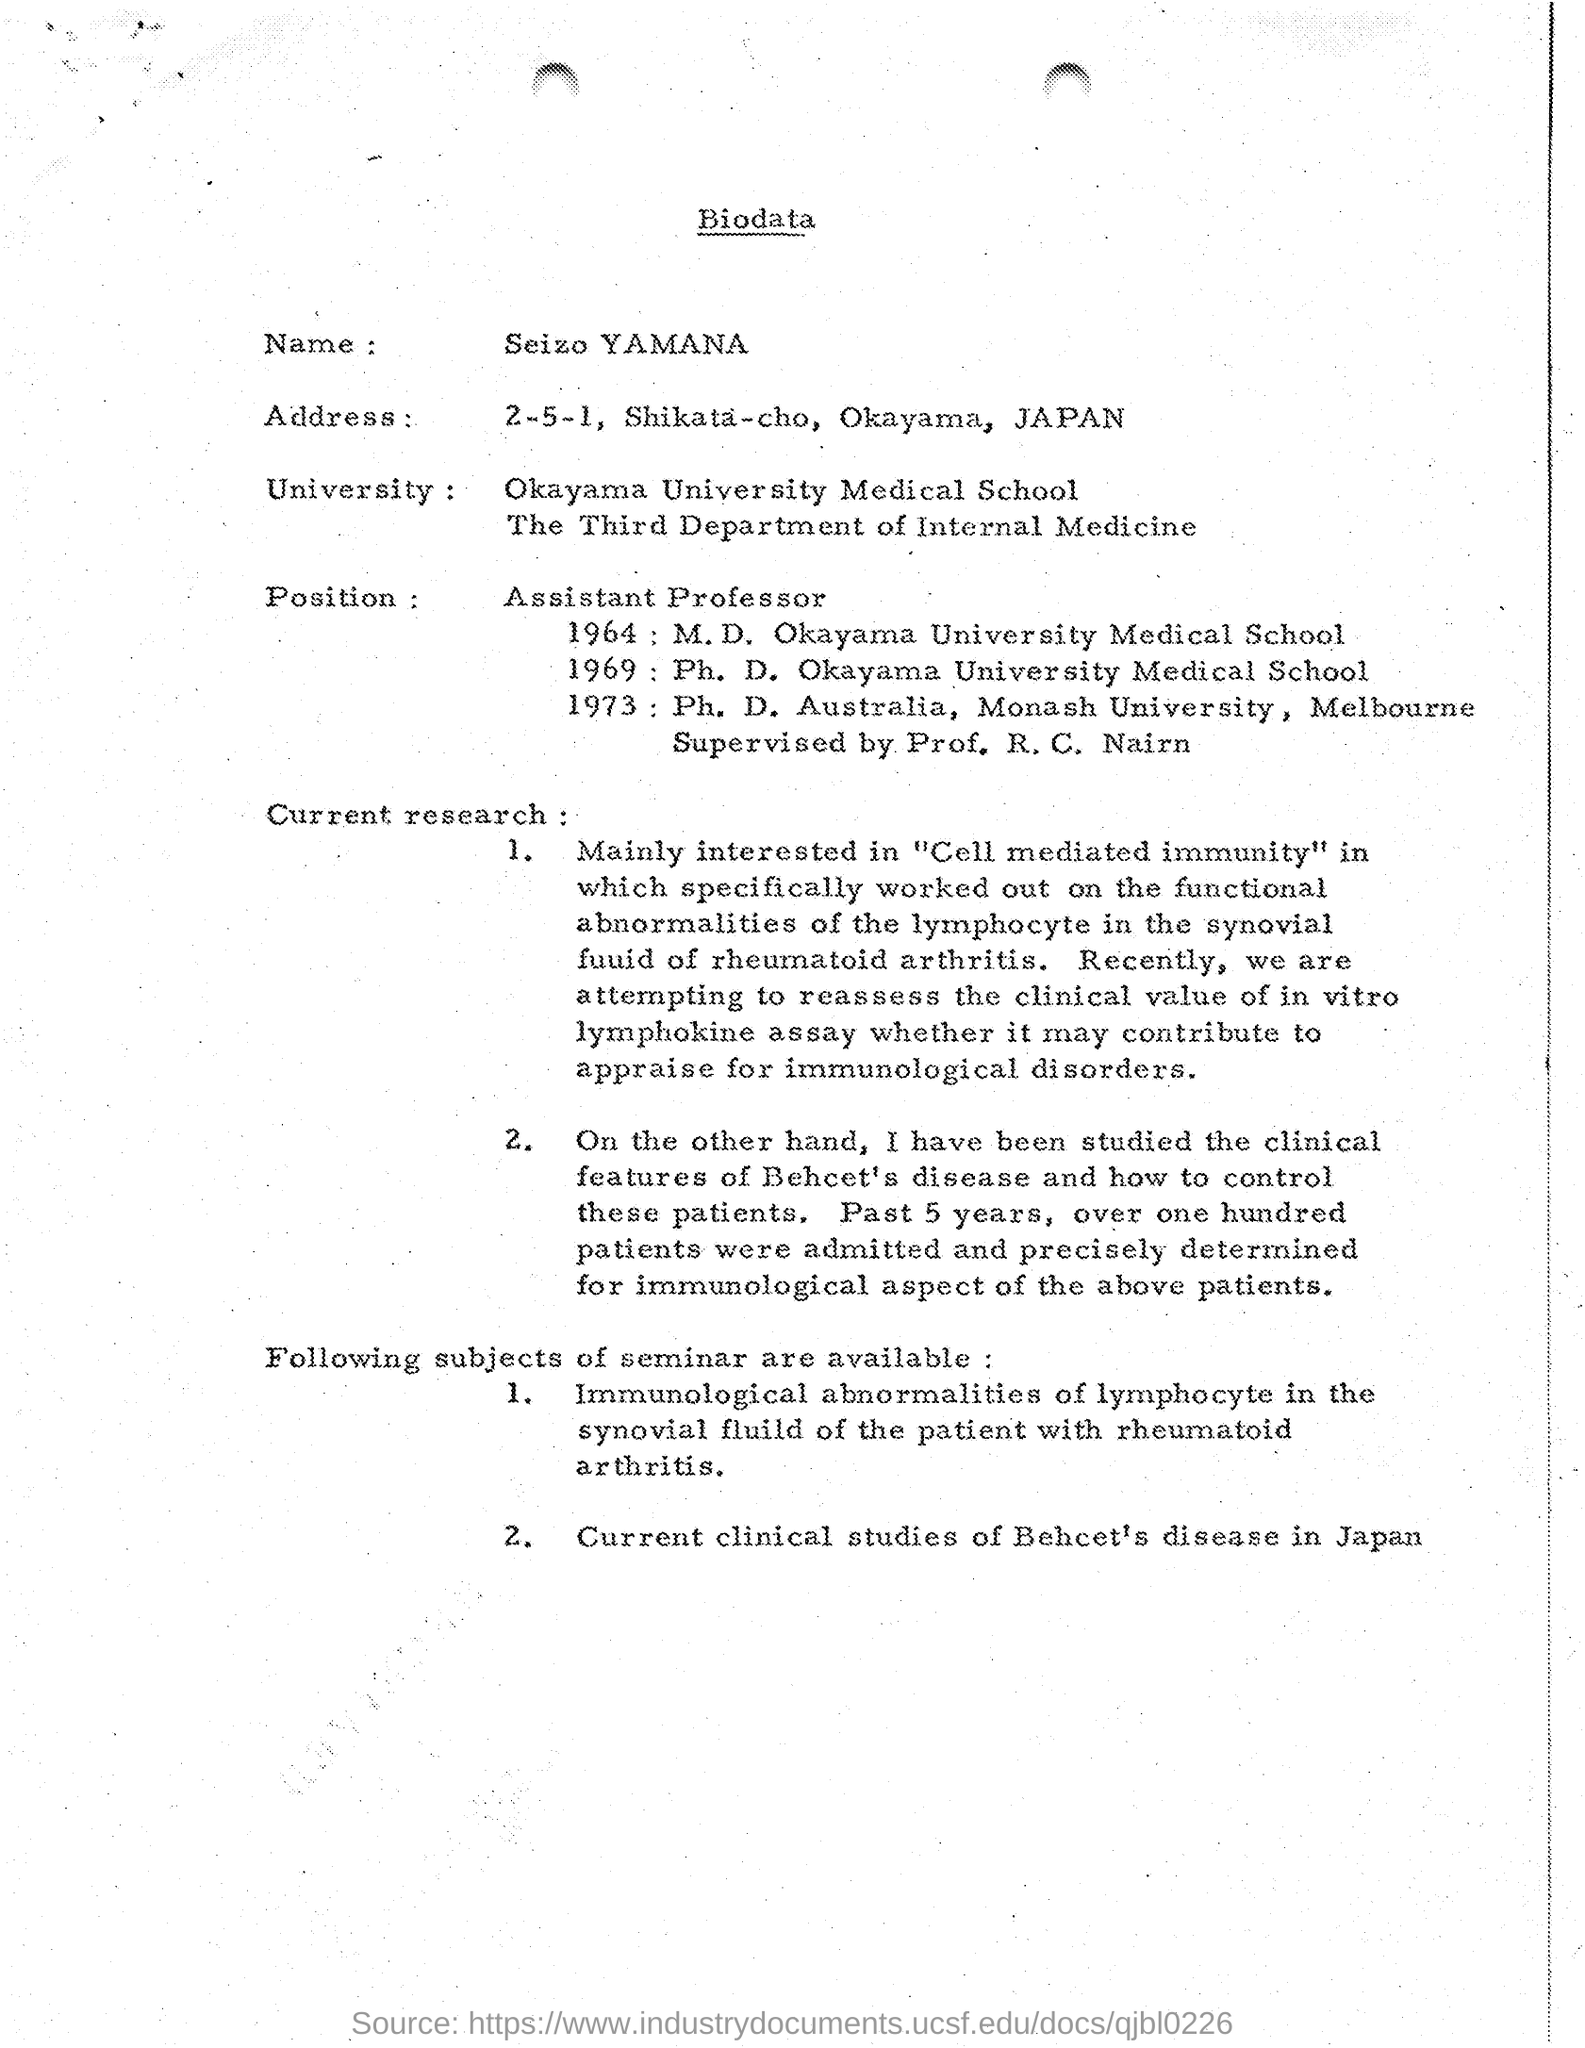Identify some key points in this picture. The biodata mentions that the position is an Assistant Professor. The name mentioned in the Biodata is Seizo Yamanaka. 